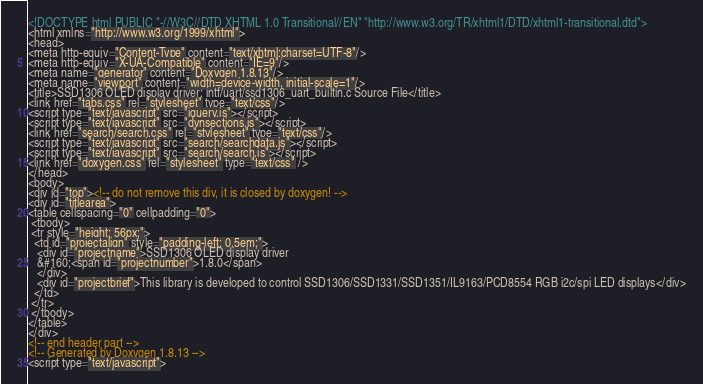Convert code to text. <code><loc_0><loc_0><loc_500><loc_500><_HTML_><!DOCTYPE html PUBLIC "-//W3C//DTD XHTML 1.0 Transitional//EN" "http://www.w3.org/TR/xhtml1/DTD/xhtml1-transitional.dtd">
<html xmlns="http://www.w3.org/1999/xhtml">
<head>
<meta http-equiv="Content-Type" content="text/xhtml;charset=UTF-8"/>
<meta http-equiv="X-UA-Compatible" content="IE=9"/>
<meta name="generator" content="Doxygen 1.8.13"/>
<meta name="viewport" content="width=device-width, initial-scale=1"/>
<title>SSD1306 OLED display driver: intf/uart/ssd1306_uart_builtin.c Source File</title>
<link href="tabs.css" rel="stylesheet" type="text/css"/>
<script type="text/javascript" src="jquery.js"></script>
<script type="text/javascript" src="dynsections.js"></script>
<link href="search/search.css" rel="stylesheet" type="text/css"/>
<script type="text/javascript" src="search/searchdata.js"></script>
<script type="text/javascript" src="search/search.js"></script>
<link href="doxygen.css" rel="stylesheet" type="text/css" />
</head>
<body>
<div id="top"><!-- do not remove this div, it is closed by doxygen! -->
<div id="titlearea">
<table cellspacing="0" cellpadding="0">
 <tbody>
 <tr style="height: 56px;">
  <td id="projectalign" style="padding-left: 0.5em;">
   <div id="projectname">SSD1306 OLED display driver
   &#160;<span id="projectnumber">1.8.0</span>
   </div>
   <div id="projectbrief">This library is developed to control SSD1306/SSD1331/SSD1351/IL9163/PCD8554 RGB i2c/spi LED displays</div>
  </td>
 </tr>
 </tbody>
</table>
</div>
<!-- end header part -->
<!-- Generated by Doxygen 1.8.13 -->
<script type="text/javascript"></code> 